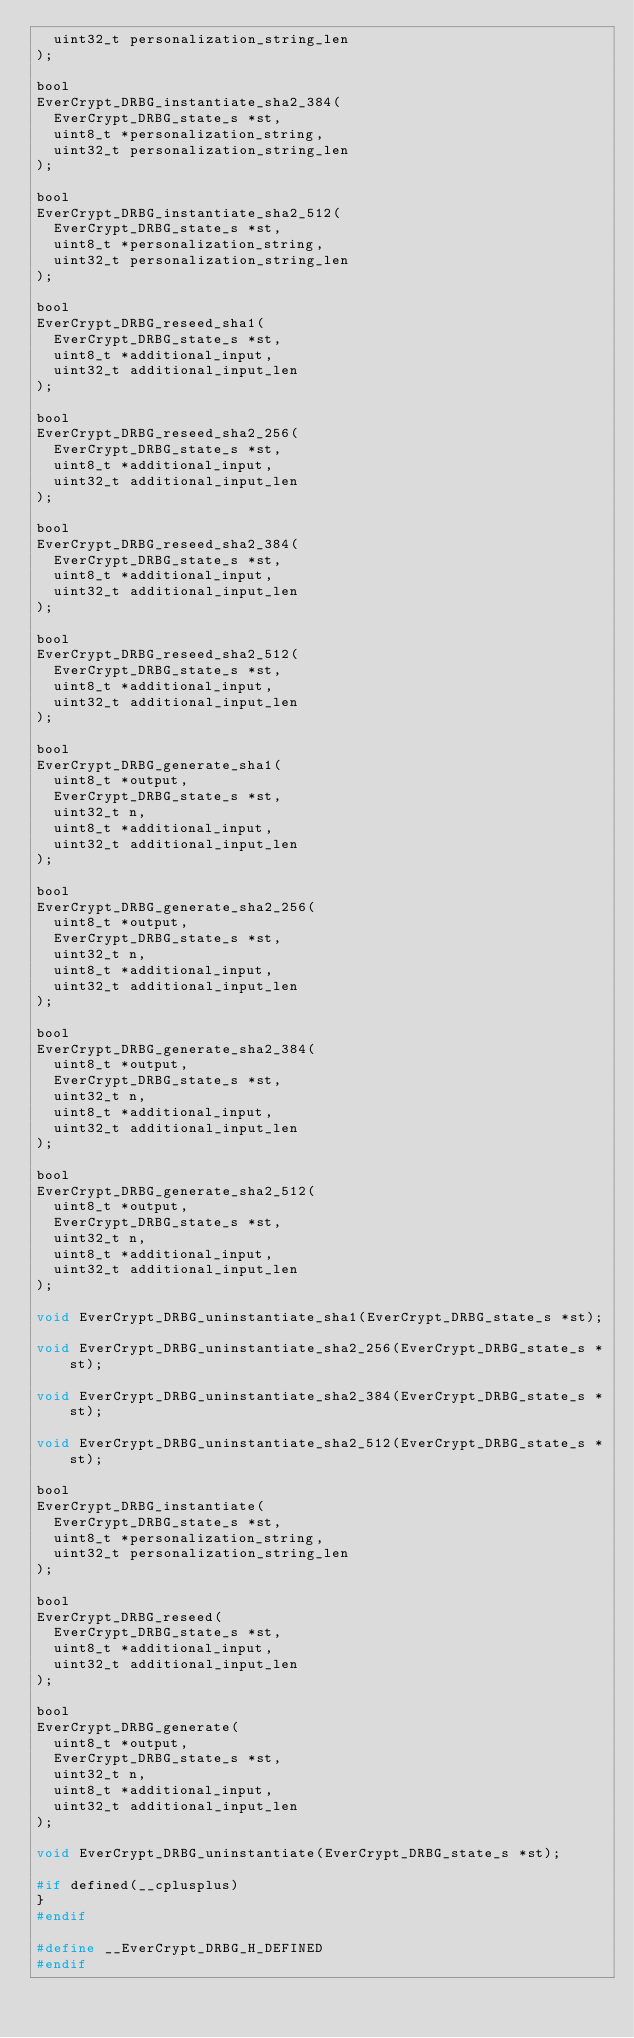Convert code to text. <code><loc_0><loc_0><loc_500><loc_500><_C_>  uint32_t personalization_string_len
);

bool
EverCrypt_DRBG_instantiate_sha2_384(
  EverCrypt_DRBG_state_s *st,
  uint8_t *personalization_string,
  uint32_t personalization_string_len
);

bool
EverCrypt_DRBG_instantiate_sha2_512(
  EverCrypt_DRBG_state_s *st,
  uint8_t *personalization_string,
  uint32_t personalization_string_len
);

bool
EverCrypt_DRBG_reseed_sha1(
  EverCrypt_DRBG_state_s *st,
  uint8_t *additional_input,
  uint32_t additional_input_len
);

bool
EverCrypt_DRBG_reseed_sha2_256(
  EverCrypt_DRBG_state_s *st,
  uint8_t *additional_input,
  uint32_t additional_input_len
);

bool
EverCrypt_DRBG_reseed_sha2_384(
  EverCrypt_DRBG_state_s *st,
  uint8_t *additional_input,
  uint32_t additional_input_len
);

bool
EverCrypt_DRBG_reseed_sha2_512(
  EverCrypt_DRBG_state_s *st,
  uint8_t *additional_input,
  uint32_t additional_input_len
);

bool
EverCrypt_DRBG_generate_sha1(
  uint8_t *output,
  EverCrypt_DRBG_state_s *st,
  uint32_t n,
  uint8_t *additional_input,
  uint32_t additional_input_len
);

bool
EverCrypt_DRBG_generate_sha2_256(
  uint8_t *output,
  EverCrypt_DRBG_state_s *st,
  uint32_t n,
  uint8_t *additional_input,
  uint32_t additional_input_len
);

bool
EverCrypt_DRBG_generate_sha2_384(
  uint8_t *output,
  EverCrypt_DRBG_state_s *st,
  uint32_t n,
  uint8_t *additional_input,
  uint32_t additional_input_len
);

bool
EverCrypt_DRBG_generate_sha2_512(
  uint8_t *output,
  EverCrypt_DRBG_state_s *st,
  uint32_t n,
  uint8_t *additional_input,
  uint32_t additional_input_len
);

void EverCrypt_DRBG_uninstantiate_sha1(EverCrypt_DRBG_state_s *st);

void EverCrypt_DRBG_uninstantiate_sha2_256(EverCrypt_DRBG_state_s *st);

void EverCrypt_DRBG_uninstantiate_sha2_384(EverCrypt_DRBG_state_s *st);

void EverCrypt_DRBG_uninstantiate_sha2_512(EverCrypt_DRBG_state_s *st);

bool
EverCrypt_DRBG_instantiate(
  EverCrypt_DRBG_state_s *st,
  uint8_t *personalization_string,
  uint32_t personalization_string_len
);

bool
EverCrypt_DRBG_reseed(
  EverCrypt_DRBG_state_s *st,
  uint8_t *additional_input,
  uint32_t additional_input_len
);

bool
EverCrypt_DRBG_generate(
  uint8_t *output,
  EverCrypt_DRBG_state_s *st,
  uint32_t n,
  uint8_t *additional_input,
  uint32_t additional_input_len
);

void EverCrypt_DRBG_uninstantiate(EverCrypt_DRBG_state_s *st);

#if defined(__cplusplus)
}
#endif

#define __EverCrypt_DRBG_H_DEFINED
#endif
</code> 